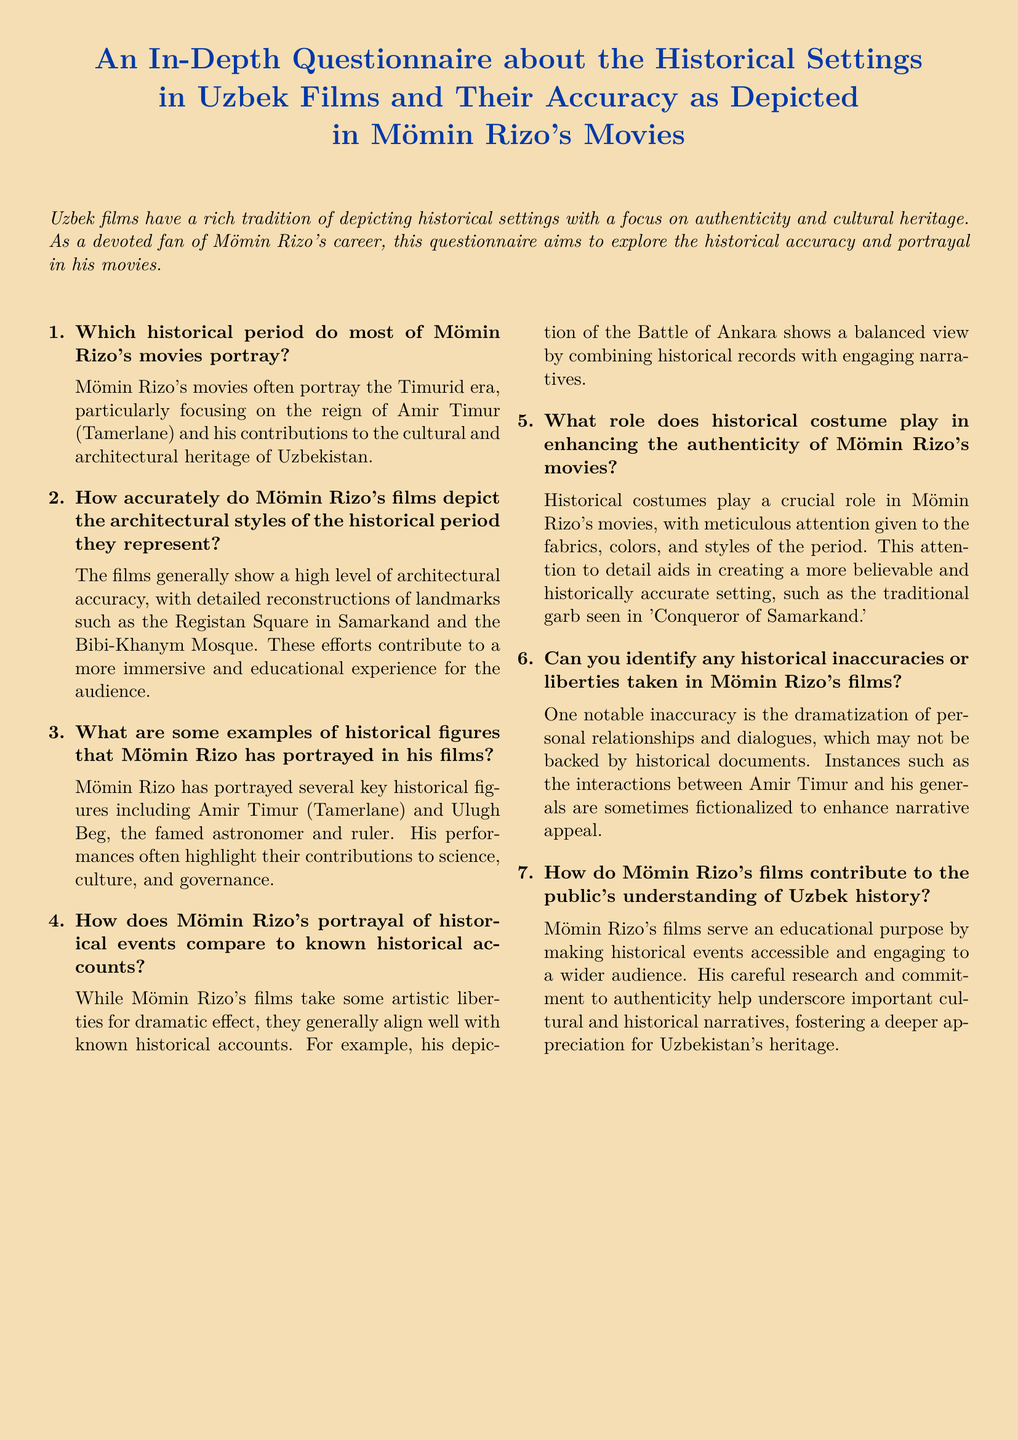Which historical period do most of Mömin Rizo's movies portray? The historical period primarily represented in Mömin Rizo's films is specified in the document.
Answer: Timurid era How accurately do Mömin Rizo's films depict architectural styles? The document states the general level of accuracy regarding architectural depictions in Rizo's movies.
Answer: High level of architectural accuracy Name a historical figure portrayed by Mömin Rizo. The document provides specific examples of historical figures represented in Rizo's films.
Answer: Amir Timur What is the role of historical costume in Rizo's movies? The document explains the importance of historical costumes in enhancing the films' authenticity.
Answer: Crucial role How do Rizo's films contribute to understanding of Uzbek history? The document outlines the educational purpose of Mömin Rizo's films in relation to history.
Answer: Educational purpose 